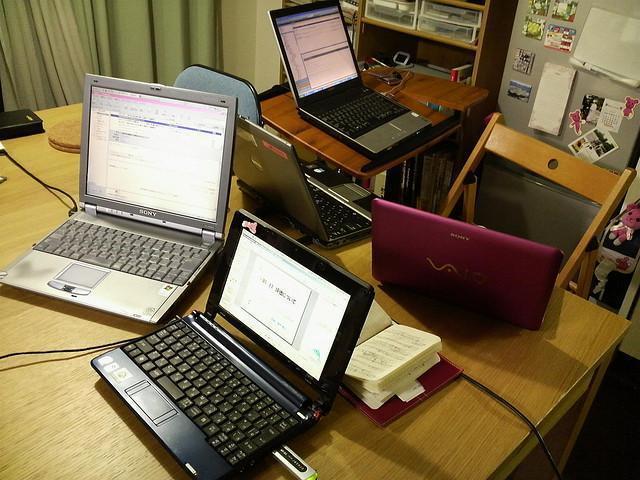How many laptops are closed in this photo?
Give a very brief answer. 0. How many chairs are there?
Give a very brief answer. 2. How many laptops are there?
Give a very brief answer. 5. How many people are wearing yellow shirt?
Give a very brief answer. 0. 